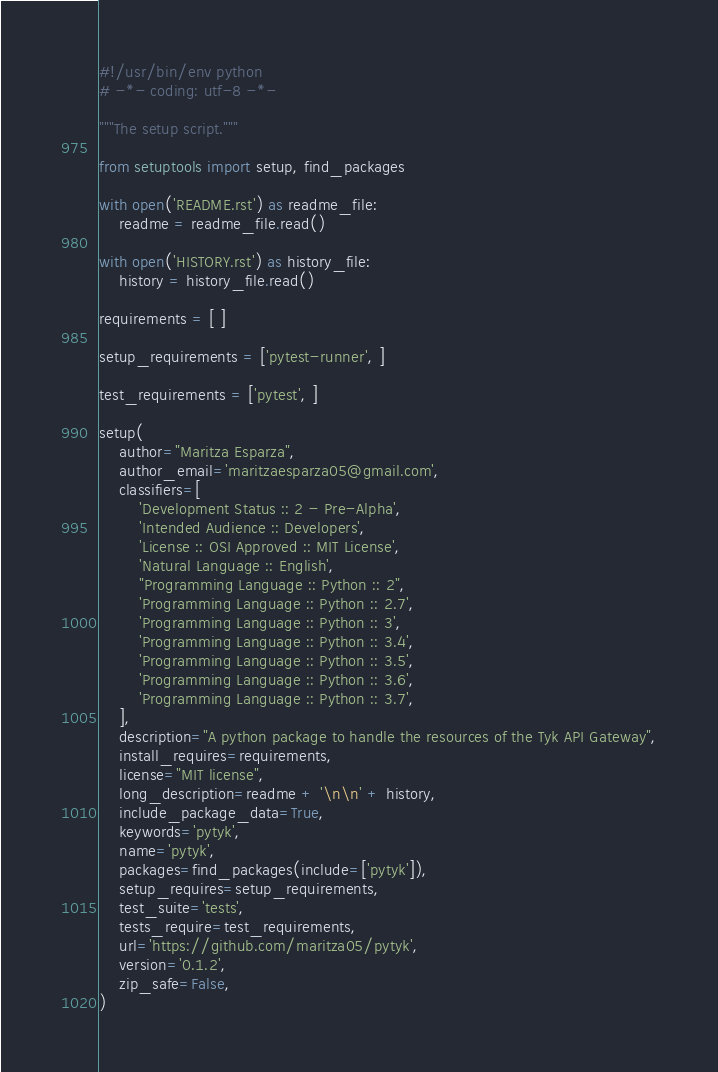<code> <loc_0><loc_0><loc_500><loc_500><_Python_>#!/usr/bin/env python
# -*- coding: utf-8 -*-

"""The setup script."""

from setuptools import setup, find_packages

with open('README.rst') as readme_file:
    readme = readme_file.read()

with open('HISTORY.rst') as history_file:
    history = history_file.read()

requirements = [ ]

setup_requirements = ['pytest-runner', ]

test_requirements = ['pytest', ]

setup(
    author="Maritza Esparza",
    author_email='maritzaesparza05@gmail.com',
    classifiers=[
        'Development Status :: 2 - Pre-Alpha',
        'Intended Audience :: Developers',
        'License :: OSI Approved :: MIT License',
        'Natural Language :: English',
        "Programming Language :: Python :: 2",
        'Programming Language :: Python :: 2.7',
        'Programming Language :: Python :: 3',
        'Programming Language :: Python :: 3.4',
        'Programming Language :: Python :: 3.5',
        'Programming Language :: Python :: 3.6',
        'Programming Language :: Python :: 3.7',
    ],
    description="A python package to handle the resources of the Tyk API Gateway",
    install_requires=requirements,
    license="MIT license",
    long_description=readme + '\n\n' + history,
    include_package_data=True,
    keywords='pytyk',
    name='pytyk',
    packages=find_packages(include=['pytyk']),
    setup_requires=setup_requirements,
    test_suite='tests',
    tests_require=test_requirements,
    url='https://github.com/maritza05/pytyk',
    version='0.1.2',
    zip_safe=False,
)
</code> 